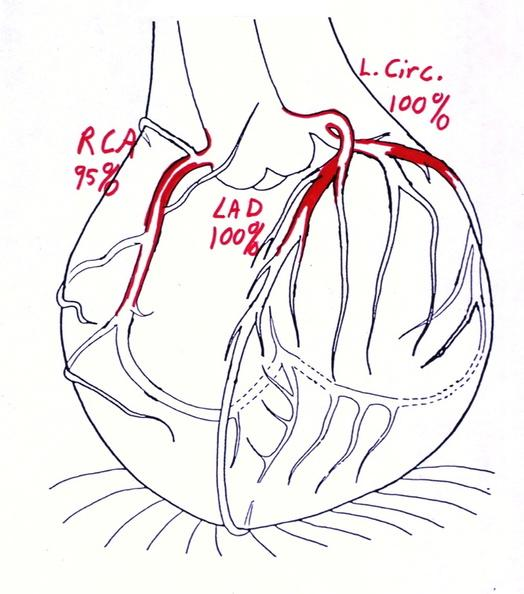what does this image show?
Answer the question using a single word or phrase. Coronary artery atherosclerosis diagram 